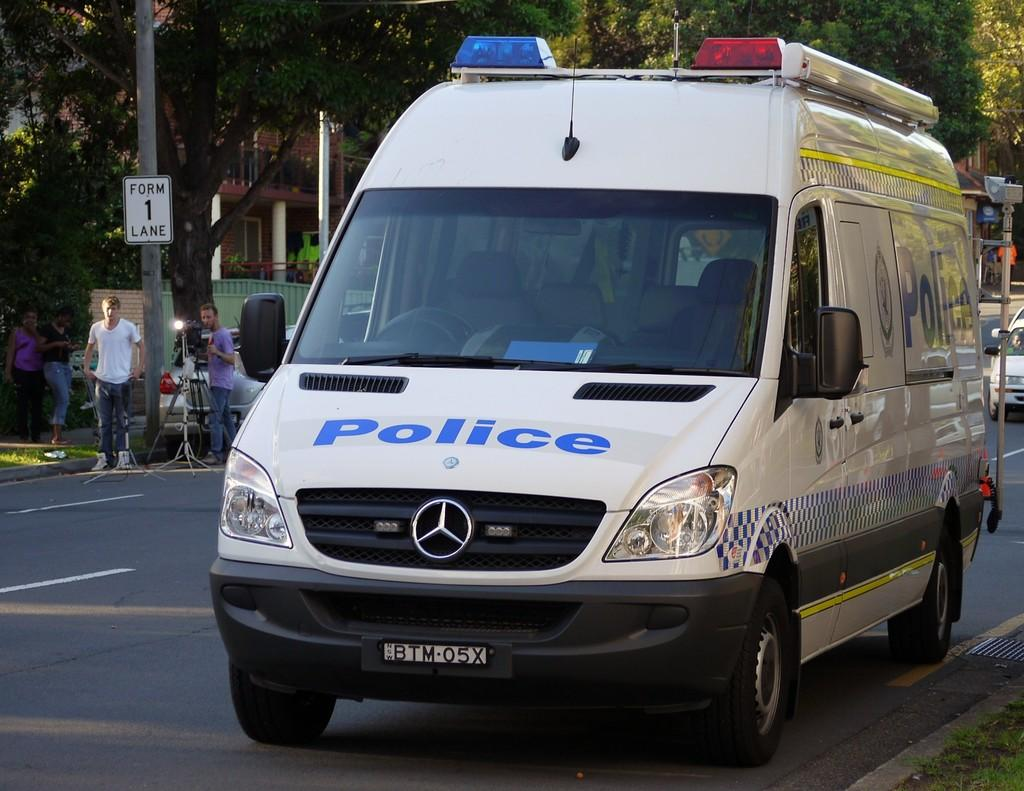<image>
Summarize the visual content of the image. White van which says POLICE in the front. 